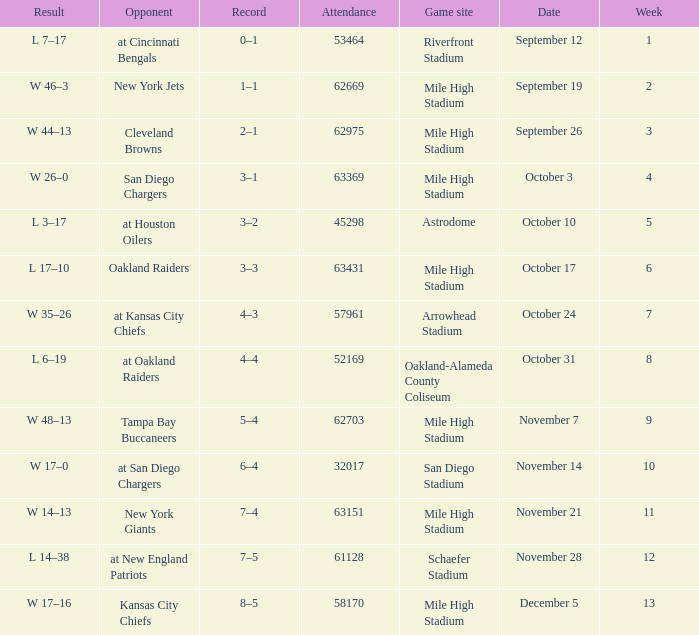What was the date of the week 4 game? October 3. 